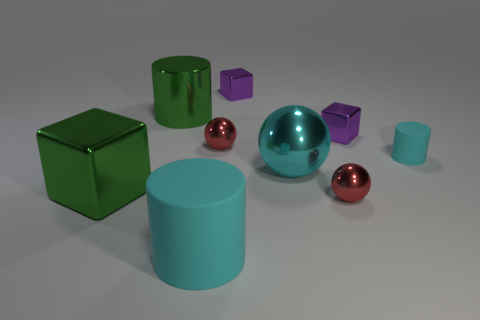The object that is made of the same material as the tiny cylinder is what shape?
Provide a succinct answer. Cylinder. There is a large cyan shiny thing; is its shape the same as the red shiny object in front of the tiny cyan rubber cylinder?
Your answer should be very brief. Yes. What is the cylinder that is on the right side of the object behind the green metal cylinder made of?
Give a very brief answer. Rubber. How many other things are the same shape as the cyan shiny thing?
Make the answer very short. 2. Do the large green thing that is behind the big cyan shiny ball and the big cyan object that is on the left side of the big cyan metallic object have the same shape?
Offer a terse response. Yes. Is there anything else that is the same material as the green cylinder?
Provide a short and direct response. Yes. What is the material of the small cyan thing?
Provide a short and direct response. Rubber. There is a cyan thing that is in front of the large green shiny cube; what material is it?
Offer a very short reply. Rubber. Is there any other thing that is the same color as the small cylinder?
Provide a succinct answer. Yes. What size is the other cyan cylinder that is made of the same material as the large cyan cylinder?
Give a very brief answer. Small. 